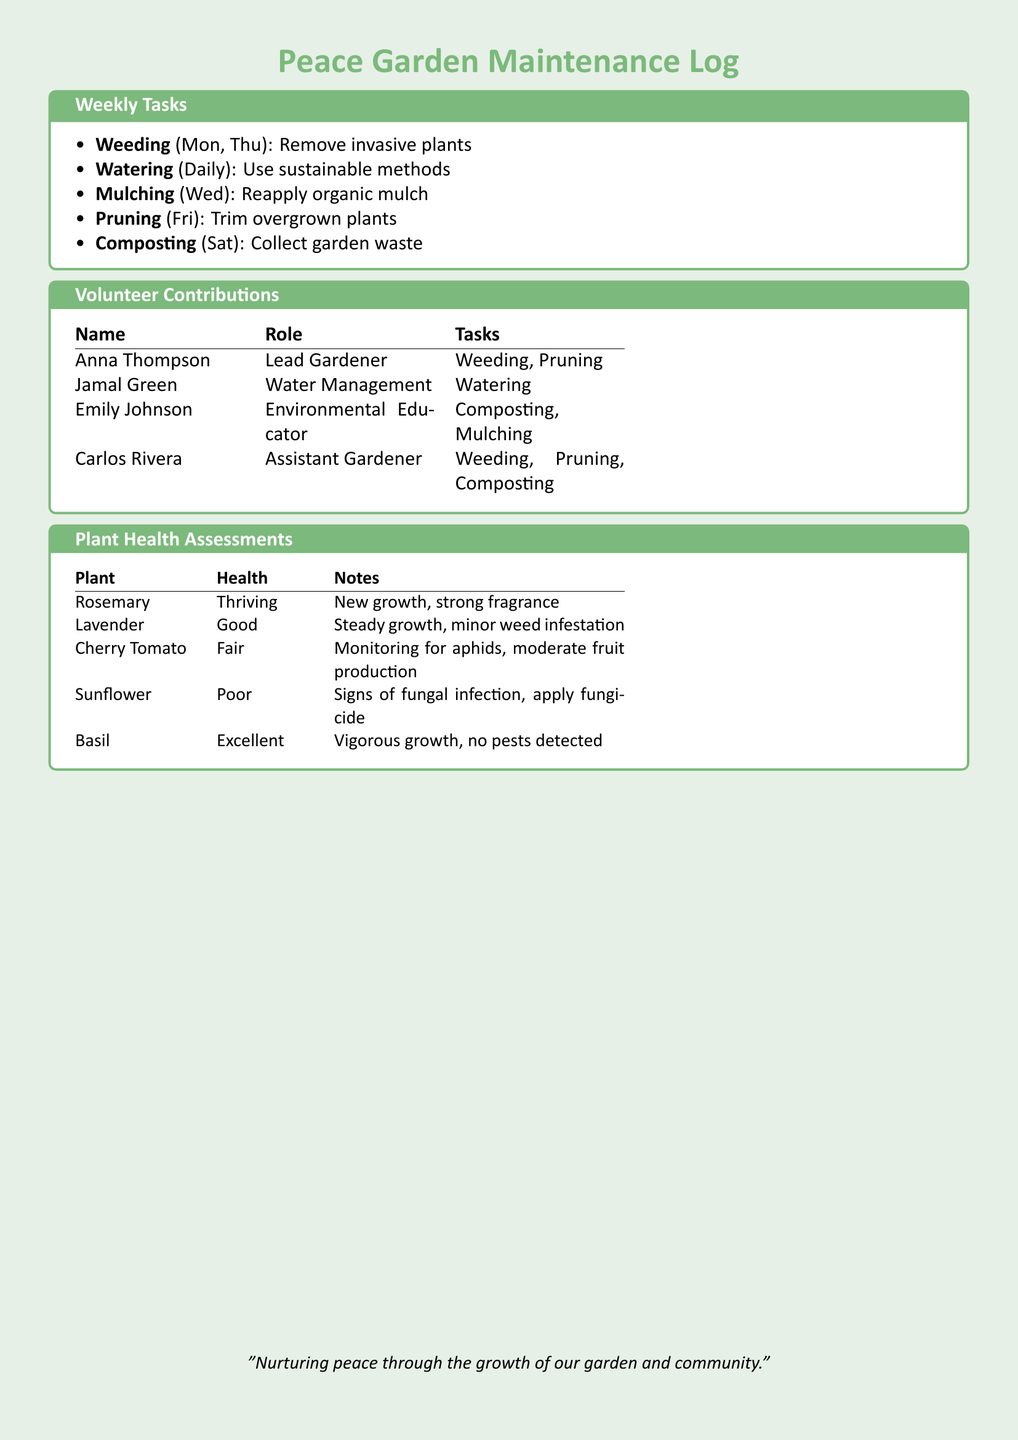What tasks are done on Mondays? Mondays involve removing invasive plants in the garden as part of the weeding task.
Answer: Weeding Who is responsible for watering the plants? The document specifies that Jamal Green is responsible for the watering tasks.
Answer: Jamal Green What is the health status of the Basil plant? The health assessment comments that the Basil plant has vigorous growth and no pests detected, categorizing its health as excellent.
Answer: Excellent Which day is designated for mulching? The document states that mulching is scheduled for Wednesdays.
Answer: Wed How many tasks does Carlos Rivera perform? By reviewing the volunteer contributions, Carlos Rivera performs three tasks: Weeding, Pruning, and Composting.
Answer: 3 What issue is noted with the Sunflower? The health assessment notes that the Sunflower has signs of a fungal infection.
Answer: Fungal infection What type of log is this document? The document is identified as a Peace Garden Maintenance Log, focusing on weekly tasks and contributions.
Answer: Maintenance Log What is the total number of volunteers listed? Counting the entries in the volunteer contributions section, there are four volunteers listed.
Answer: 4 Which plant has a fair health status? The Cherry Tomato plant is mentioned in the document with a health status of fair.
Answer: Cherry Tomato 